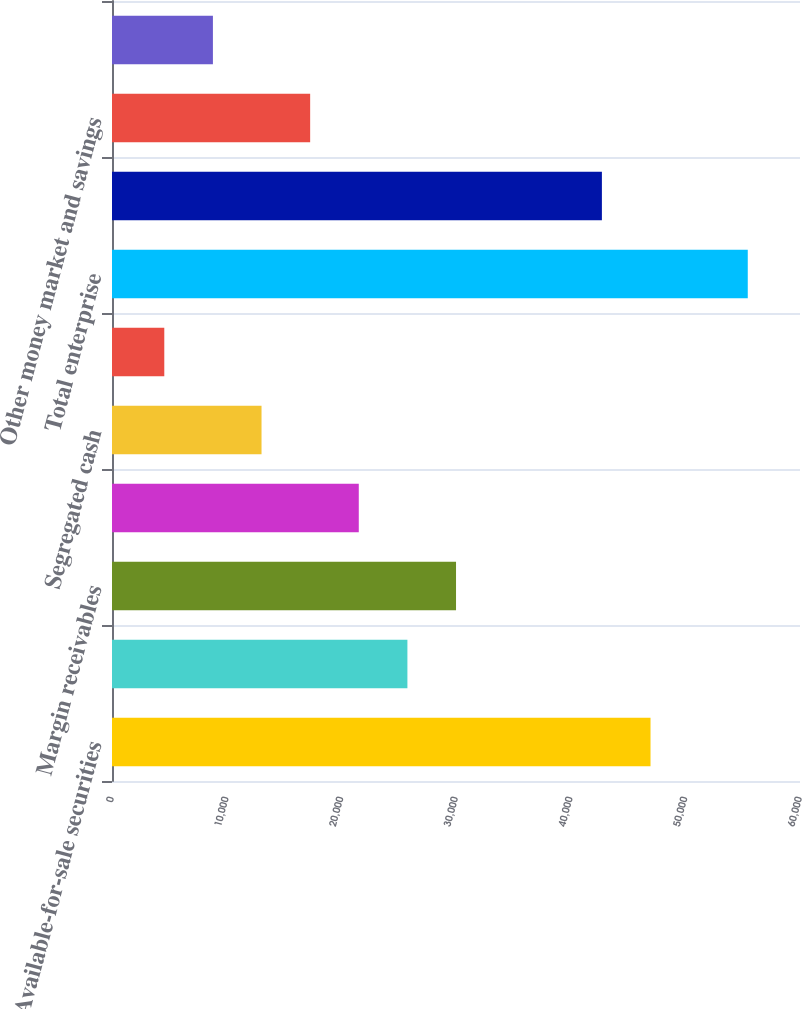<chart> <loc_0><loc_0><loc_500><loc_500><bar_chart><fcel>Available-for-sale securities<fcel>Held-to-maturity securities<fcel>Margin receivables<fcel>Cash and equivalents<fcel>Segregated cash<fcel>Securities borrowed and other<fcel>Total enterprise<fcel>Complete savings deposits<fcel>Other money market and savings<fcel>Checking deposits<nl><fcel>46964<fcel>25762<fcel>30002.4<fcel>21521.5<fcel>13040.7<fcel>4559.91<fcel>55444.8<fcel>42723.6<fcel>17281.1<fcel>8800.32<nl></chart> 